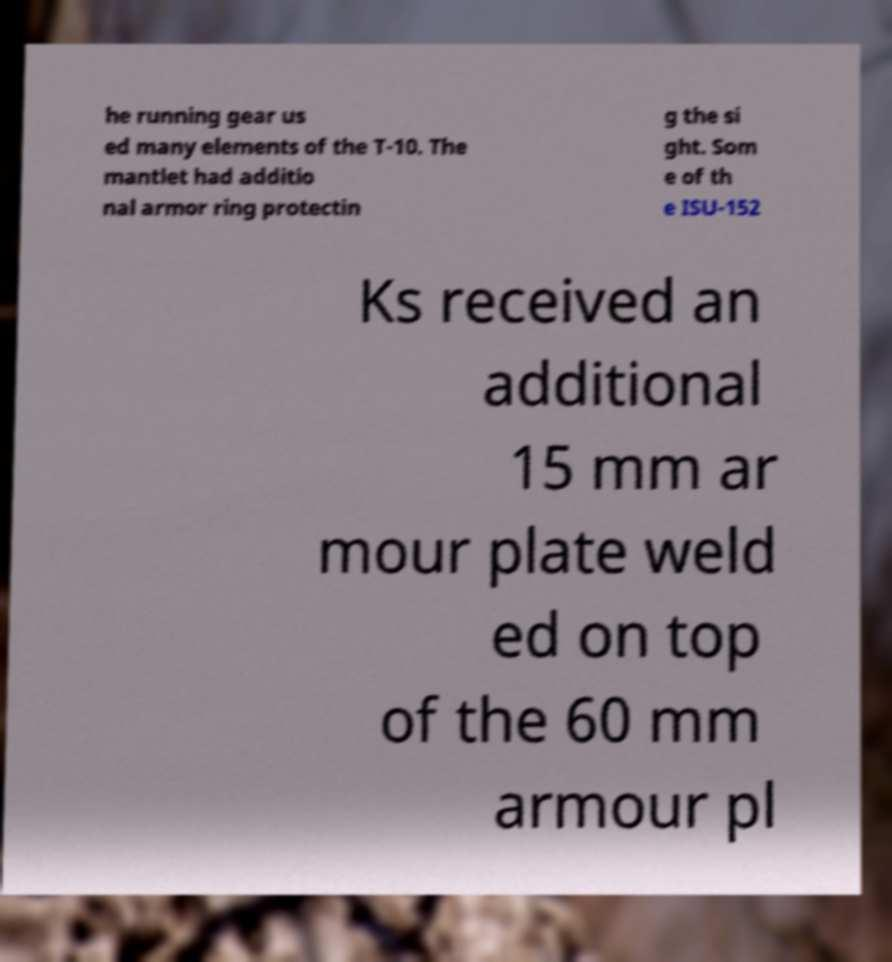I need the written content from this picture converted into text. Can you do that? he running gear us ed many elements of the T-10. The mantlet had additio nal armor ring protectin g the si ght. Som e of th e ISU-152 Ks received an additional 15 mm ar mour plate weld ed on top of the 60 mm armour pl 